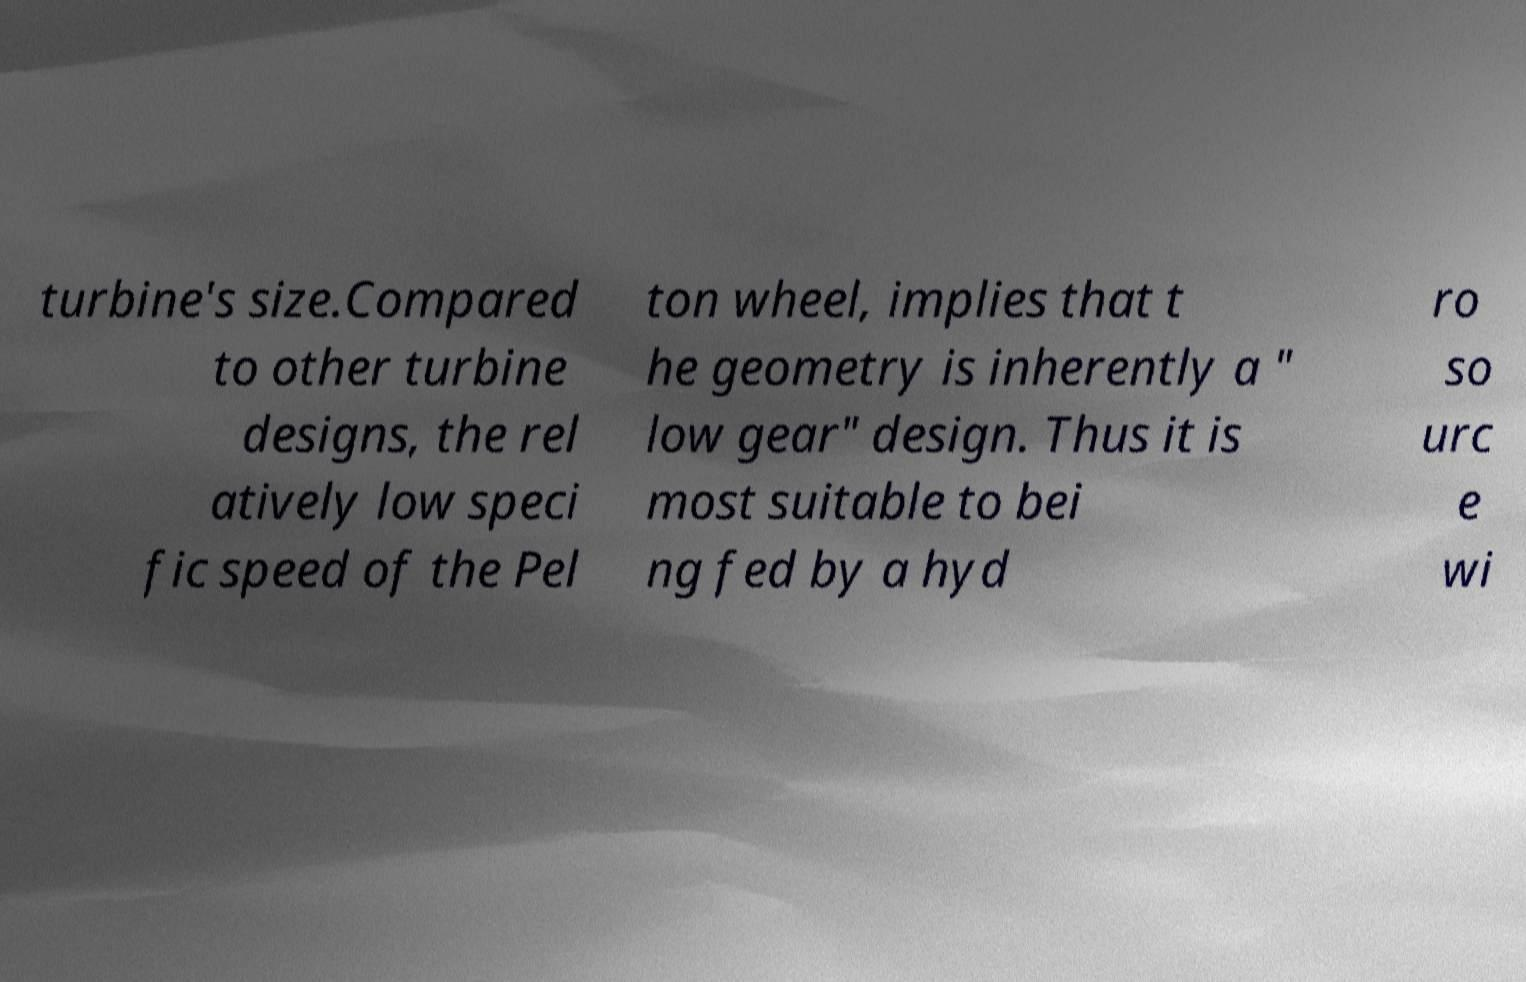Please read and relay the text visible in this image. What does it say? turbine's size.Compared to other turbine designs, the rel atively low speci fic speed of the Pel ton wheel, implies that t he geometry is inherently a " low gear" design. Thus it is most suitable to bei ng fed by a hyd ro so urc e wi 